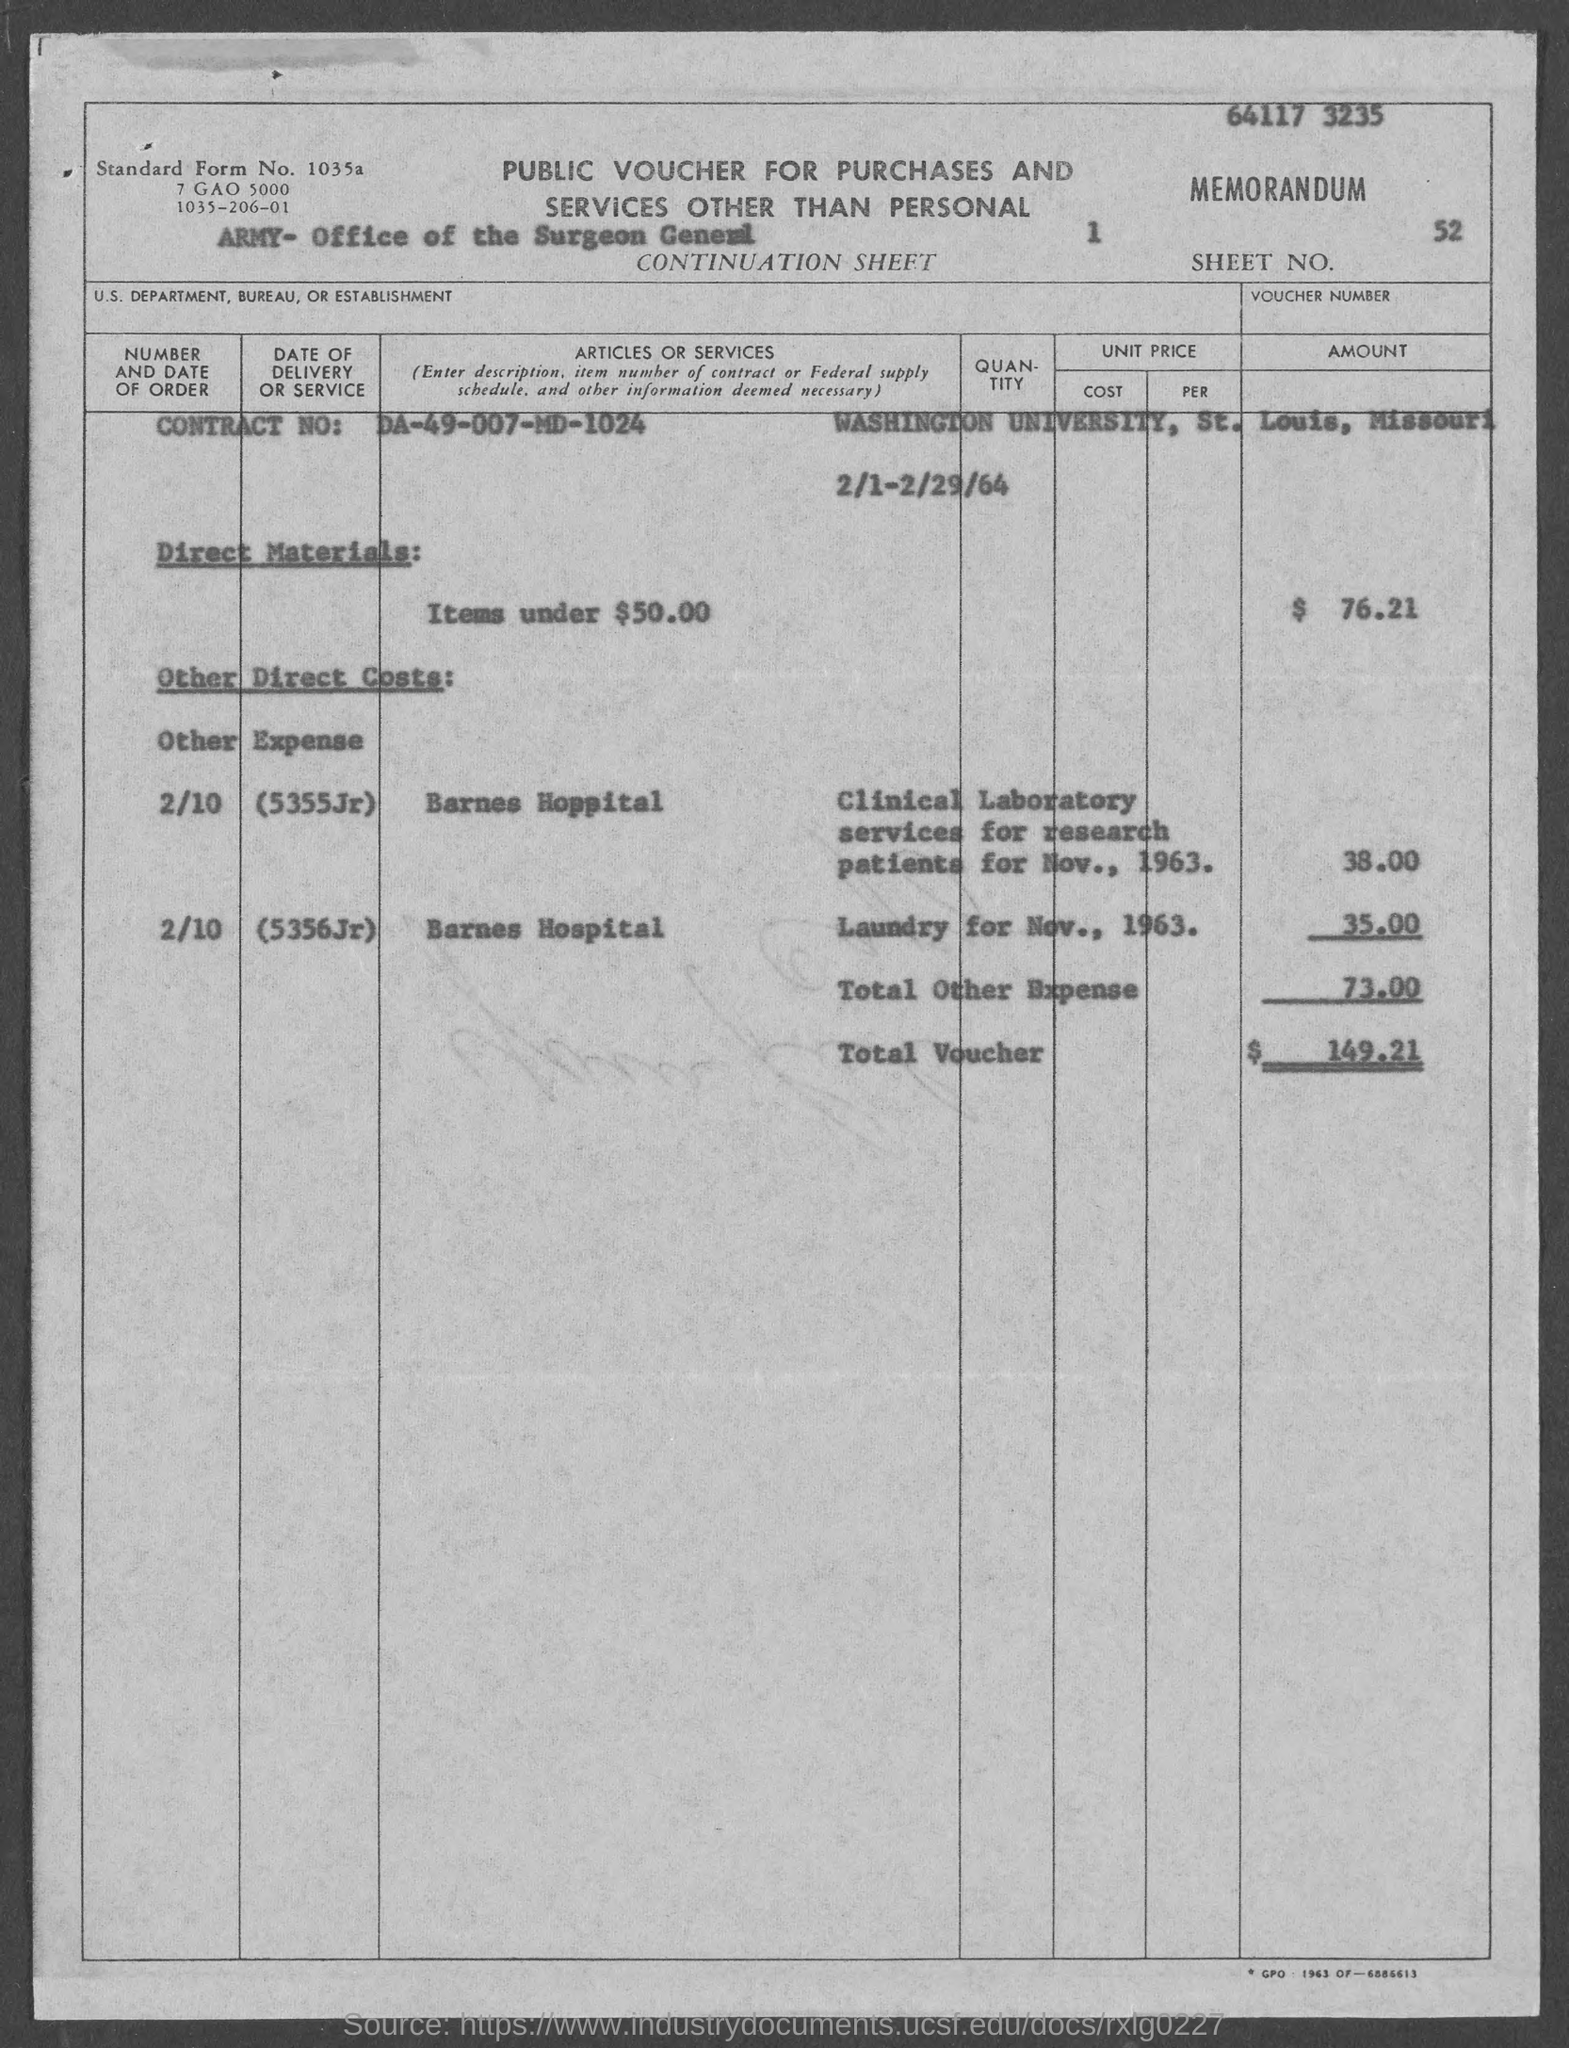Specify some key components in this picture. The U.S. Department, Bureau, or Establishment specified in the voucher is the Army's Office of the Surgeon General. The voucher number provided in the document is 52. Public vouchers are given here. The contract number mentioned in the voucher is da-49-007-md-1024. The total voucher amount mentioned in the document is $149.21. 